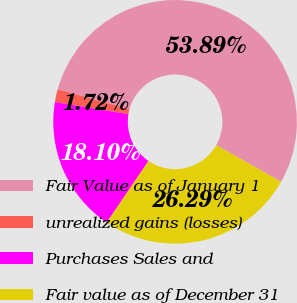Convert chart to OTSL. <chart><loc_0><loc_0><loc_500><loc_500><pie_chart><fcel>Fair Value as of January 1<fcel>unrealized gains (losses)<fcel>Purchases Sales and<fcel>Fair value as of December 31<nl><fcel>53.88%<fcel>1.72%<fcel>18.1%<fcel>26.29%<nl></chart> 